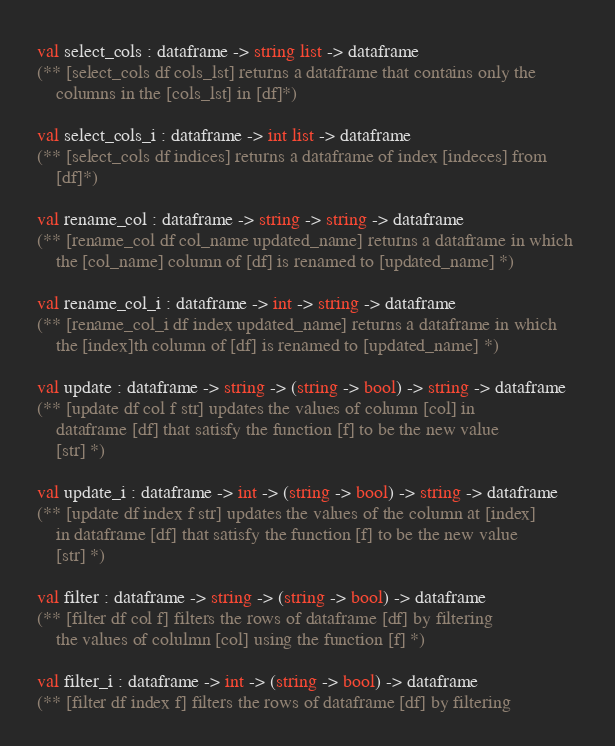<code> <loc_0><loc_0><loc_500><loc_500><_OCaml_>val select_cols : dataframe -> string list -> dataframe
(** [select_cols df cols_lst] returns a dataframe that contains only the
    columns in the [cols_lst] in [df]*)

val select_cols_i : dataframe -> int list -> dataframe
(** [select_cols df indices] returns a dataframe of index [indeces] from
    [df]*)

val rename_col : dataframe -> string -> string -> dataframe
(** [rename_col df col_name updated_name] returns a dataframe in which 
    the [col_name] column of [df] is renamed to [updated_name] *)

val rename_col_i : dataframe -> int -> string -> dataframe
(** [rename_col_i df index updated_name] returns a dataframe in which 
    the [index]th column of [df] is renamed to [updated_name] *)

val update : dataframe -> string -> (string -> bool) -> string -> dataframe
(** [update df col f str] updates the values of column [col] in
    dataframe [df] that satisfy the function [f] to be the new value
    [str] *)

val update_i : dataframe -> int -> (string -> bool) -> string -> dataframe
(** [update df index f str] updates the values of the column at [index]
    in dataframe [df] that satisfy the function [f] to be the new value
    [str] *)

val filter : dataframe -> string -> (string -> bool) -> dataframe
(** [filter df col f] filters the rows of dataframe [df] by filtering
    the values of colulmn [col] using the function [f] *)

val filter_i : dataframe -> int -> (string -> bool) -> dataframe
(** [filter df index f] filters the rows of dataframe [df] by filtering</code> 